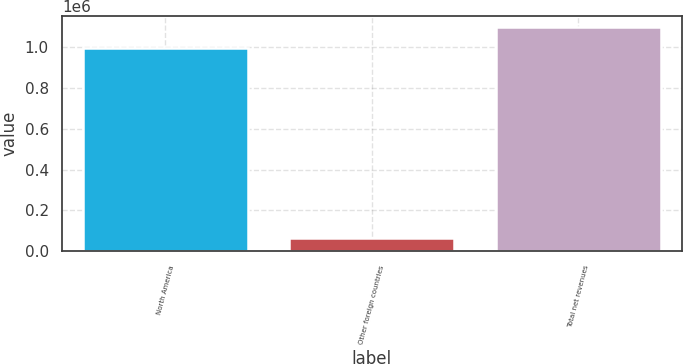Convert chart to OTSL. <chart><loc_0><loc_0><loc_500><loc_500><bar_chart><fcel>North America<fcel>Other foreign countries<fcel>Total net revenues<nl><fcel>997816<fcel>66111<fcel>1.0976e+06<nl></chart> 